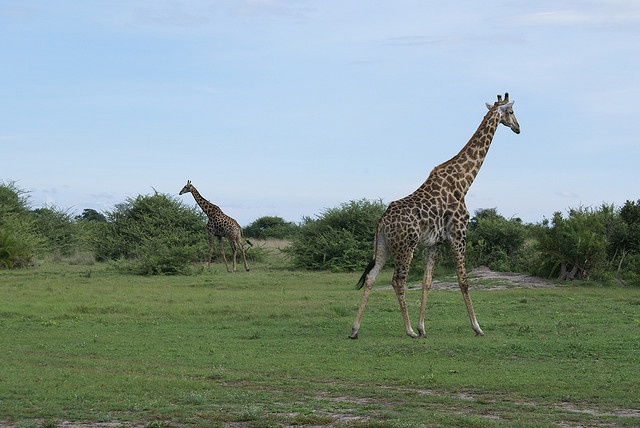Describe the objects in this image and their specific colors. I can see giraffe in lightblue, gray, black, darkgreen, and darkgray tones and giraffe in lightblue, black, and gray tones in this image. 